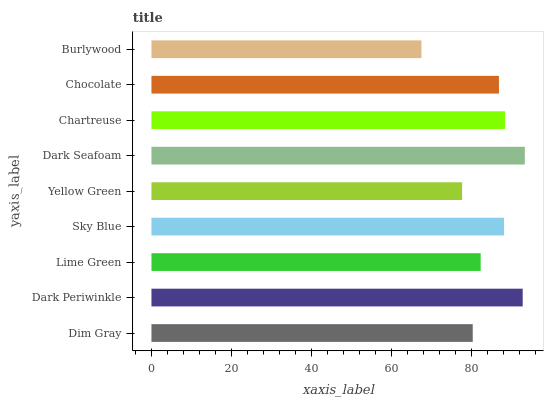Is Burlywood the minimum?
Answer yes or no. Yes. Is Dark Seafoam the maximum?
Answer yes or no. Yes. Is Dark Periwinkle the minimum?
Answer yes or no. No. Is Dark Periwinkle the maximum?
Answer yes or no. No. Is Dark Periwinkle greater than Dim Gray?
Answer yes or no. Yes. Is Dim Gray less than Dark Periwinkle?
Answer yes or no. Yes. Is Dim Gray greater than Dark Periwinkle?
Answer yes or no. No. Is Dark Periwinkle less than Dim Gray?
Answer yes or no. No. Is Chocolate the high median?
Answer yes or no. Yes. Is Chocolate the low median?
Answer yes or no. Yes. Is Burlywood the high median?
Answer yes or no. No. Is Dark Periwinkle the low median?
Answer yes or no. No. 